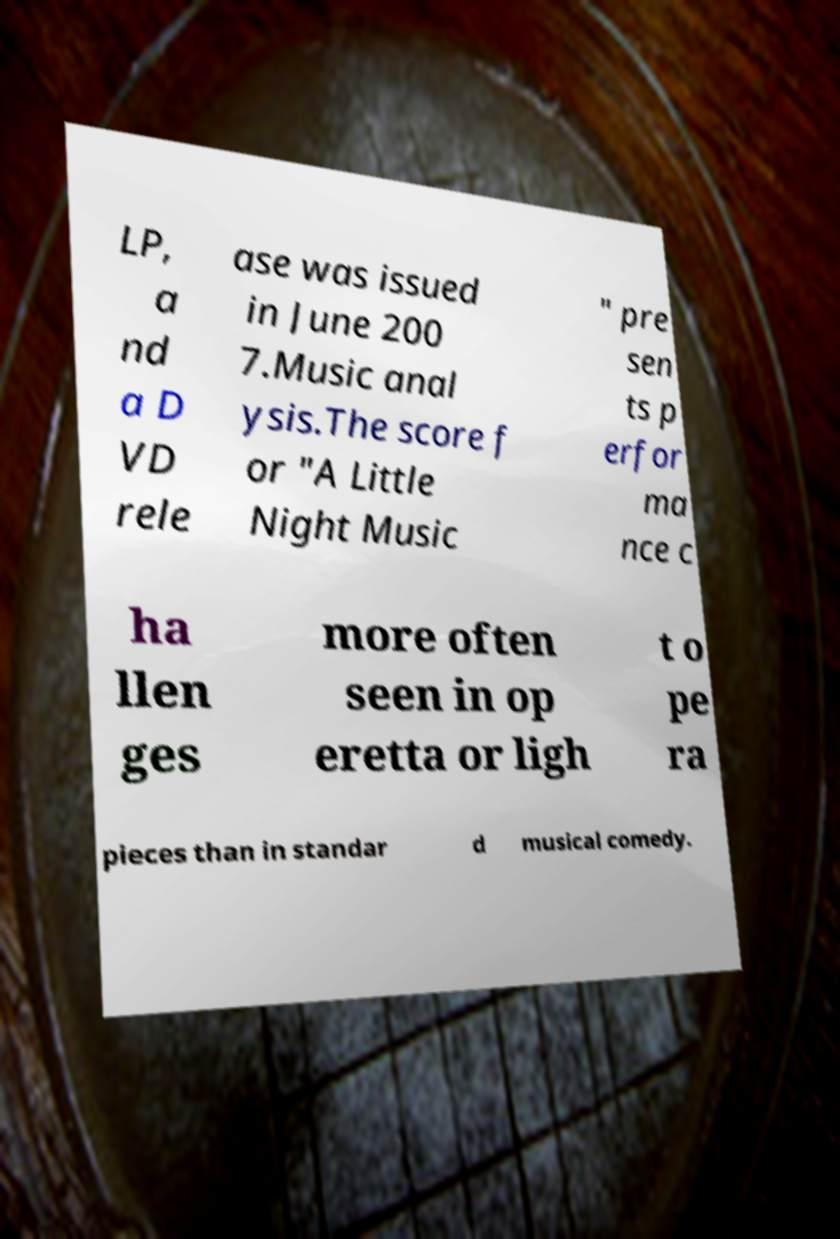I need the written content from this picture converted into text. Can you do that? LP, a nd a D VD rele ase was issued in June 200 7.Music anal ysis.The score f or "A Little Night Music " pre sen ts p erfor ma nce c ha llen ges more often seen in op eretta or ligh t o pe ra pieces than in standar d musical comedy. 